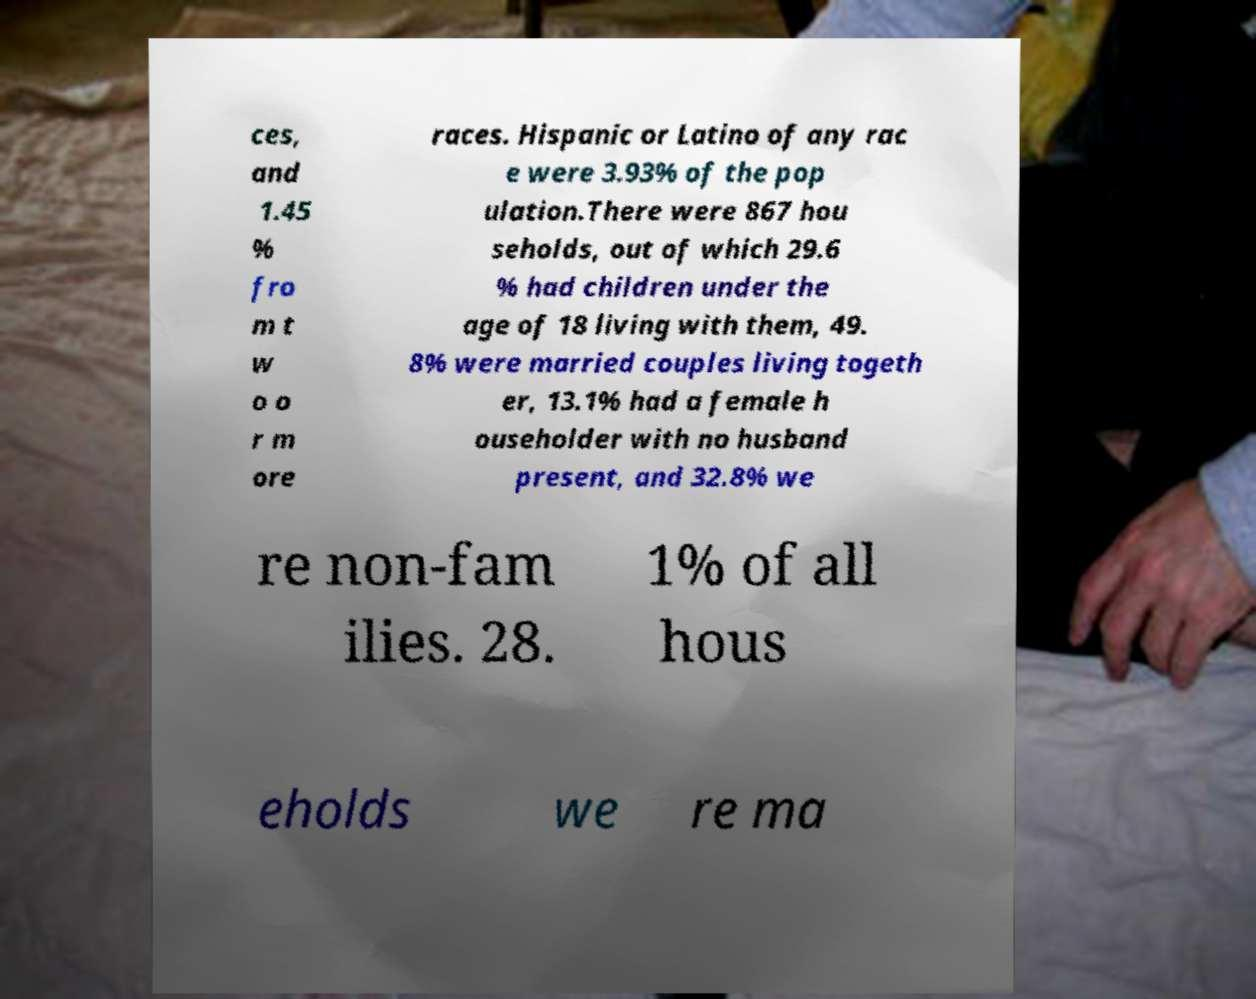There's text embedded in this image that I need extracted. Can you transcribe it verbatim? ces, and 1.45 % fro m t w o o r m ore races. Hispanic or Latino of any rac e were 3.93% of the pop ulation.There were 867 hou seholds, out of which 29.6 % had children under the age of 18 living with them, 49. 8% were married couples living togeth er, 13.1% had a female h ouseholder with no husband present, and 32.8% we re non-fam ilies. 28. 1% of all hous eholds we re ma 